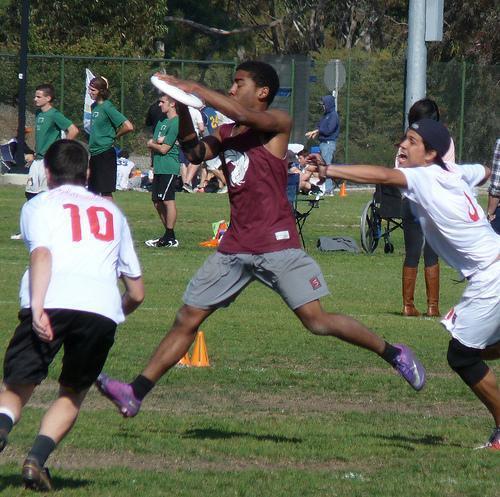How many people in this picture are wearing boots?
Give a very brief answer. 1. 